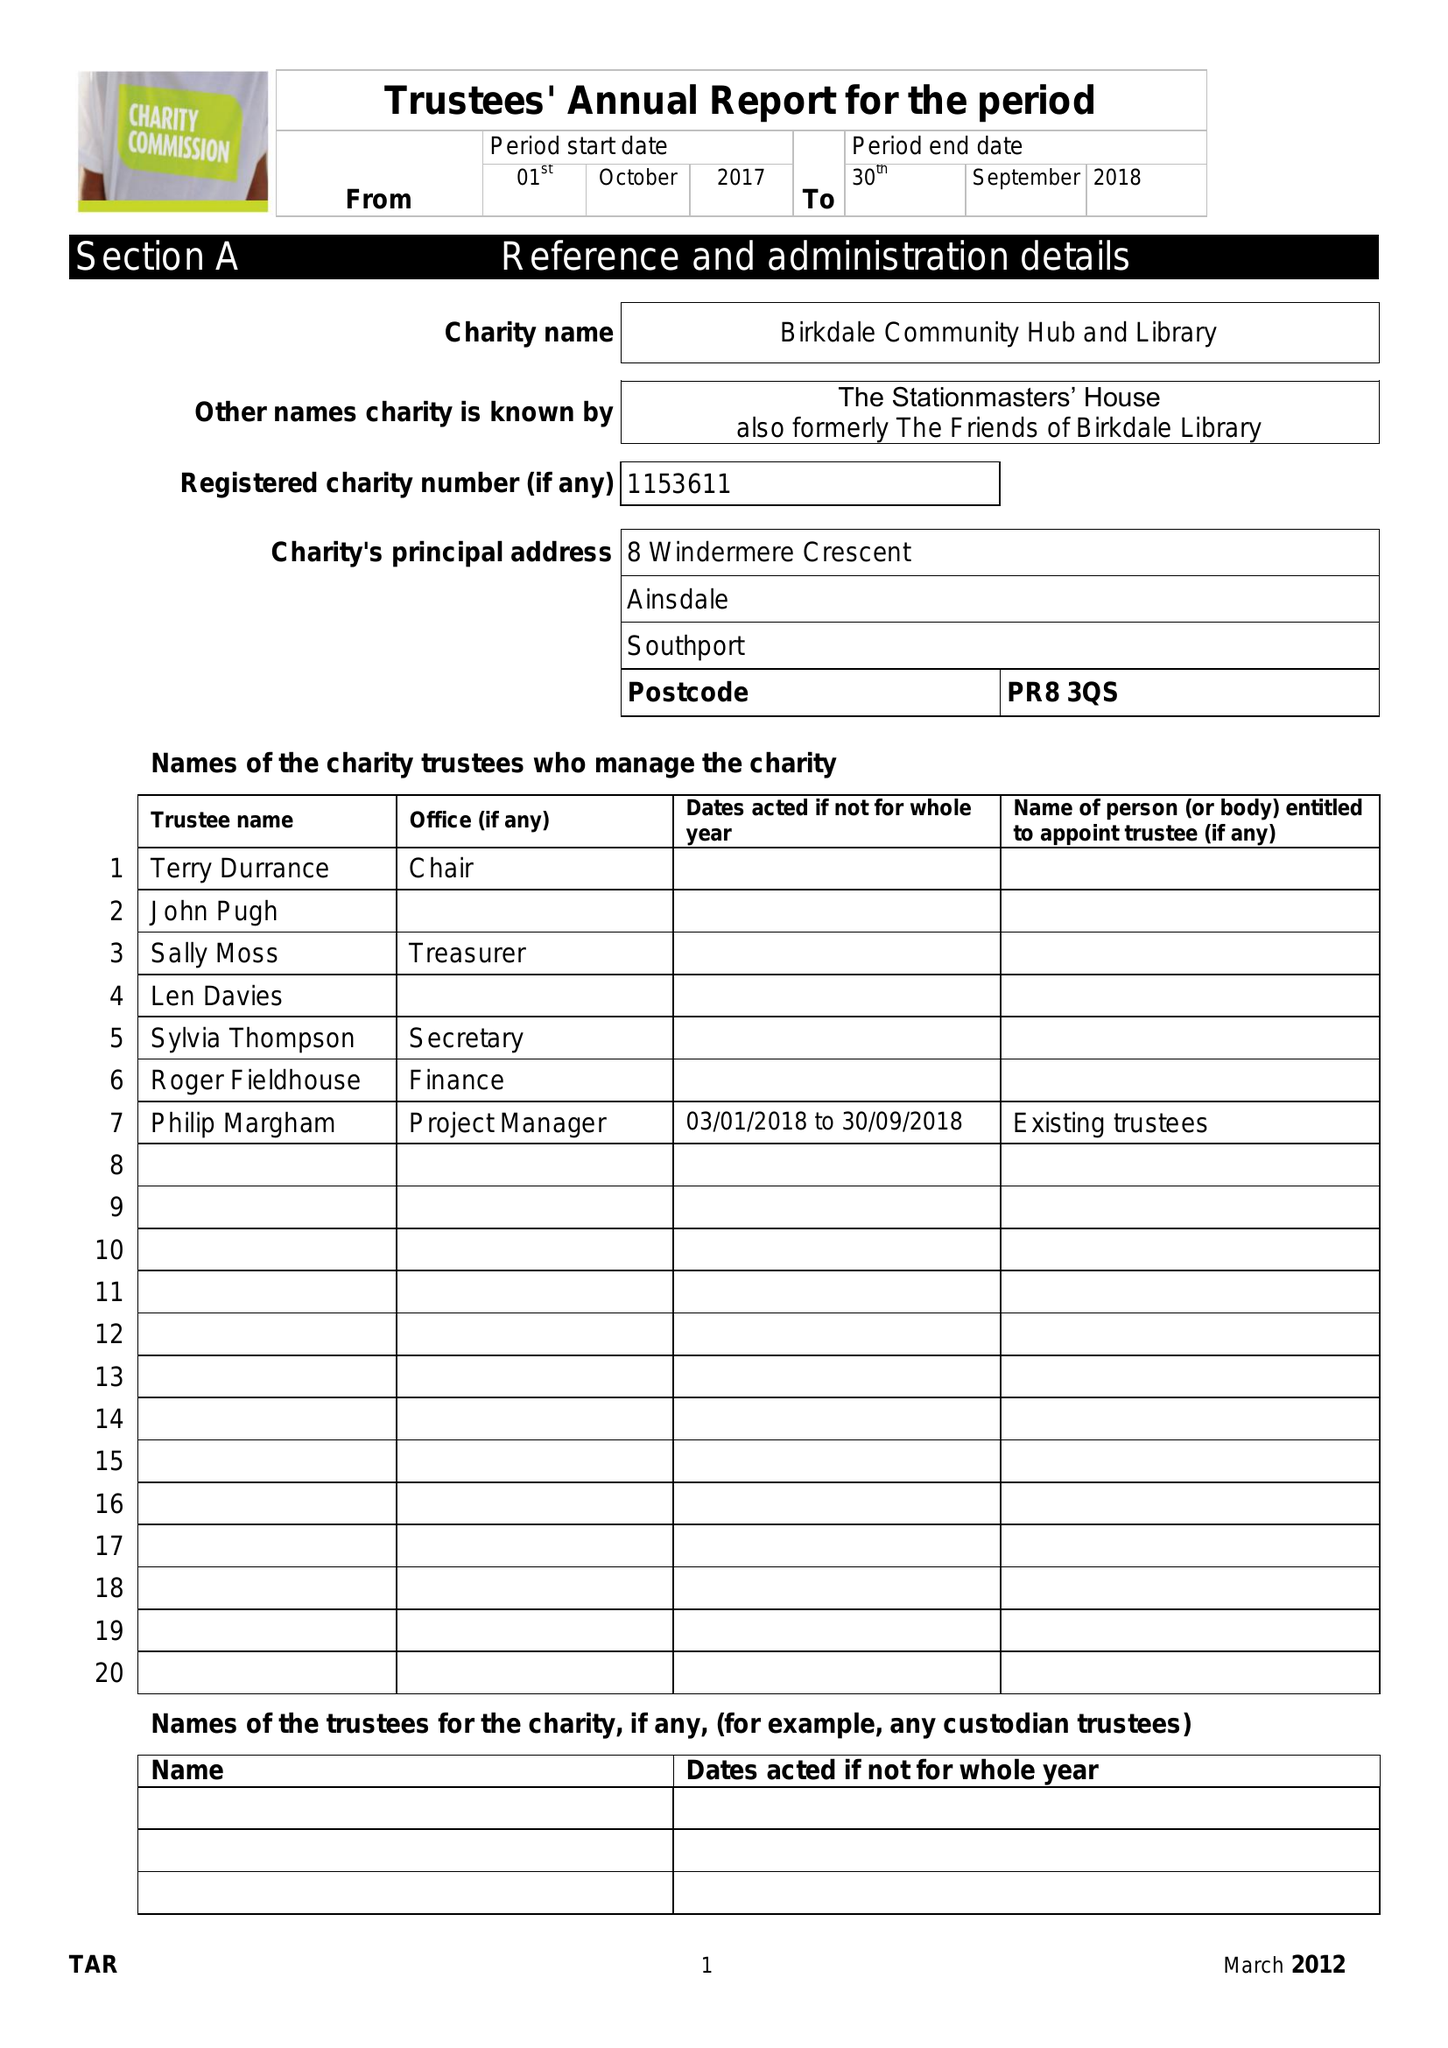What is the value for the address__post_town?
Answer the question using a single word or phrase. SOUTHPORT 